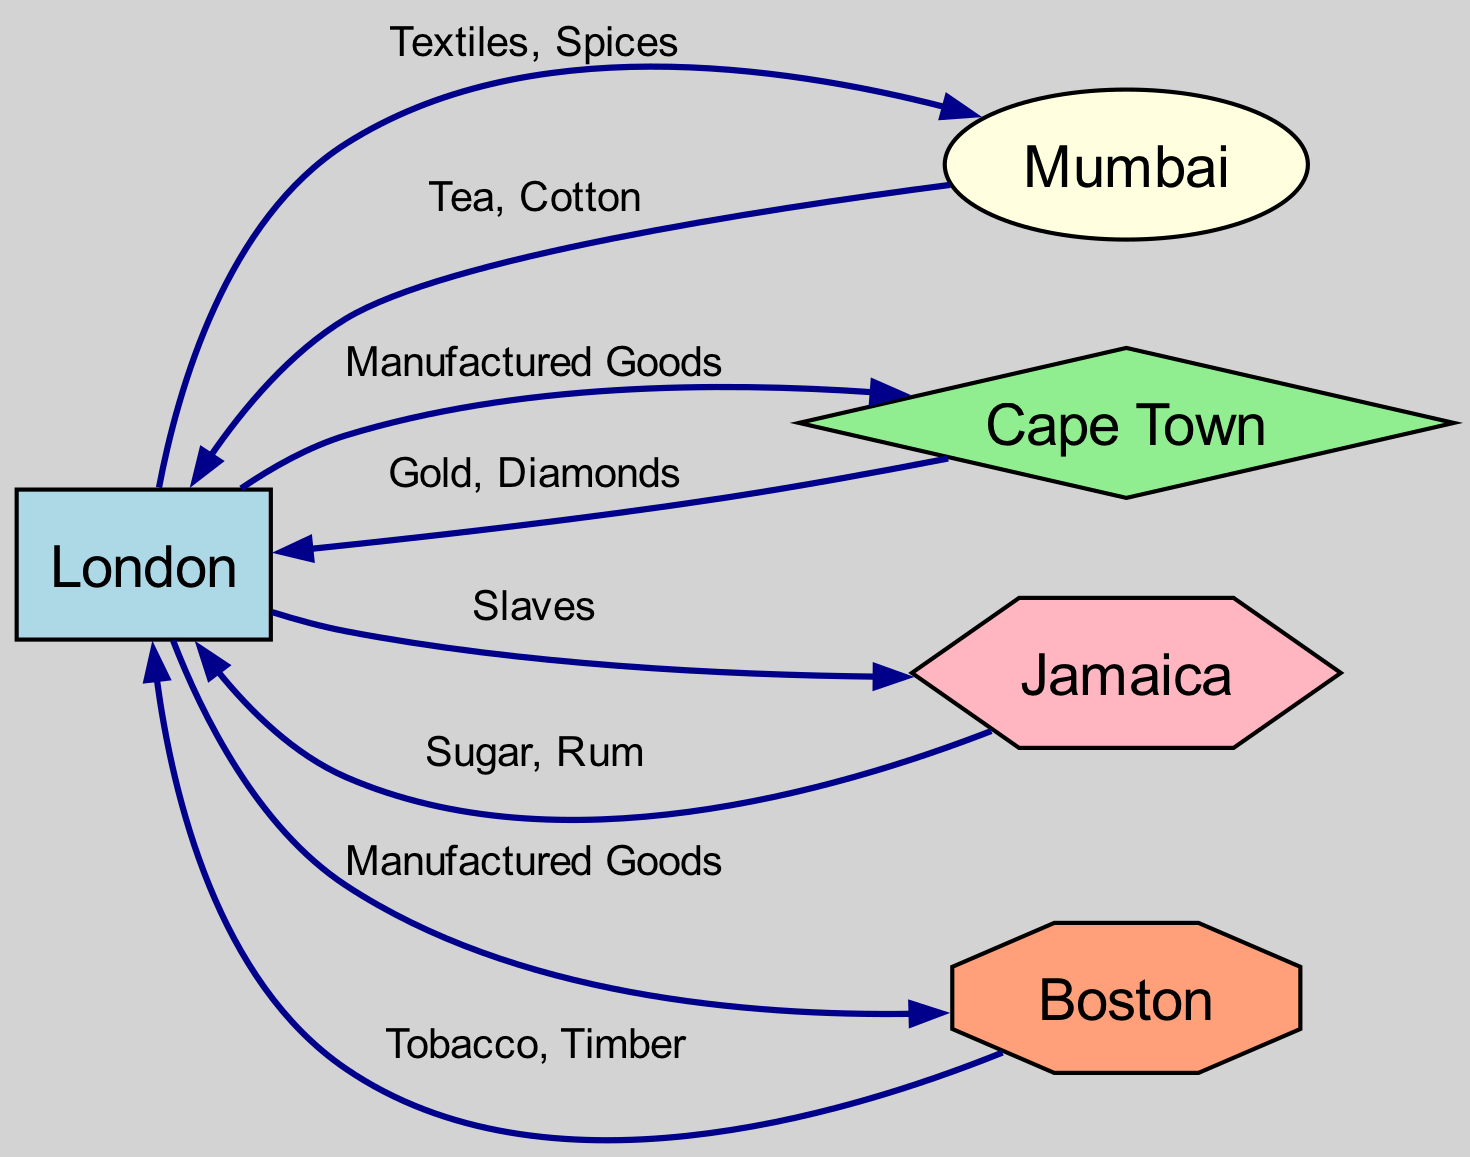What are the key ports represented in the diagram? The diagram includes the following key ports: London, Mumbai, Cape Town, Jamaica, and Boston. This can be determined by listing all the nodes present in the graph.
Answer: London, Mumbai, Cape Town, Jamaica, Boston How many edges are in the diagram? By counting the edges listed in the data, we find there are a total of 8 edges connecting the ports.
Answer: 8 Which goods flow from London to Jamaica? The edge from London to Jamaica is labeled "Slaves," which indicates that this is the good being transported from London to Jamaica.
Answer: Slaves What goods flow from Cape Town to London? The goods flowing from Cape Town to London, according to the diagram's edge, are labeled "Gold, Diamonds," which represent the resources being exported from Cape Town to London.
Answer: Gold, Diamonds Which port has a direct connection to both London and Cape Town? The port of Cape Town has a direct outflow of goods to London, indicating a direct connection from Cape Town to London. Additionally, London also has a connection to Cape Town.
Answer: Cape Town What kind of port is associated with Mumbai? Mumbai is classified as an Asian Port, as indicated by its type in the nodes section of the graph.
Answer: Asian Port Which two ports exchange goods related to tobacco? The exchange related to tobacco occurs between Boston and London, as noted by the edge from Boston to London labeled "Tobacco, Timber."
Answer: Boston and London What is the direction of flow for textiles in the diagram? The flow of textiles is directed from London to Mumbai, as indicated by the edge labeled "Textiles, Spices" connecting these two ports.
Answer: London to Mumbai What type of goods is Jamaica known for exporting to London? The edge from Jamaica to London is labeled "Sugar, Rum," indicating these are the goods that Jamaica exports to London.
Answer: Sugar, Rum 